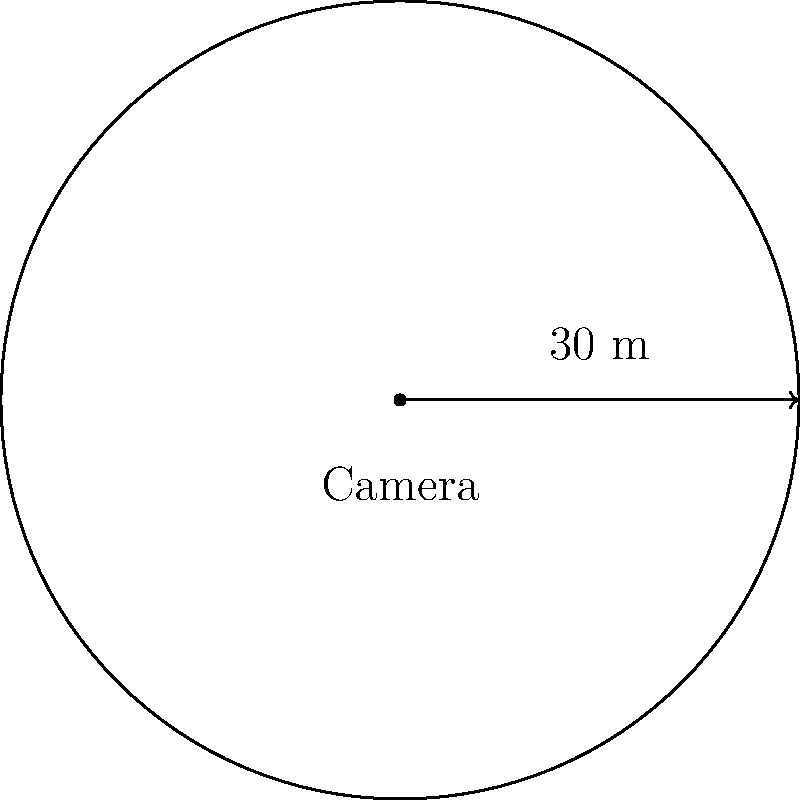A new surveillance camera is being installed in a city square. The camera's coverage area forms a perfect circle with a radius of 30 meters. What is the total area, in square meters, that this camera can monitor? Round your answer to the nearest whole number. To find the area of the circular surveillance zone, we need to use the formula for the area of a circle:

$$A = \pi r^2$$

Where:
$A$ = area
$\pi$ = pi (approximately 3.14159)
$r$ = radius

Given:
Radius $(r) = 30$ meters

Step 1: Substitute the values into the formula
$$A = \pi (30)^2$$

Step 2: Calculate the square of the radius
$$A = \pi (900)$$

Step 3: Multiply by π
$$A = 2827.43... \text{ square meters}$$

Step 4: Round to the nearest whole number
$$A \approx 2827 \text{ square meters}$$

Therefore, the surveillance camera can monitor an area of approximately 2827 square meters.
Answer: 2827 square meters 